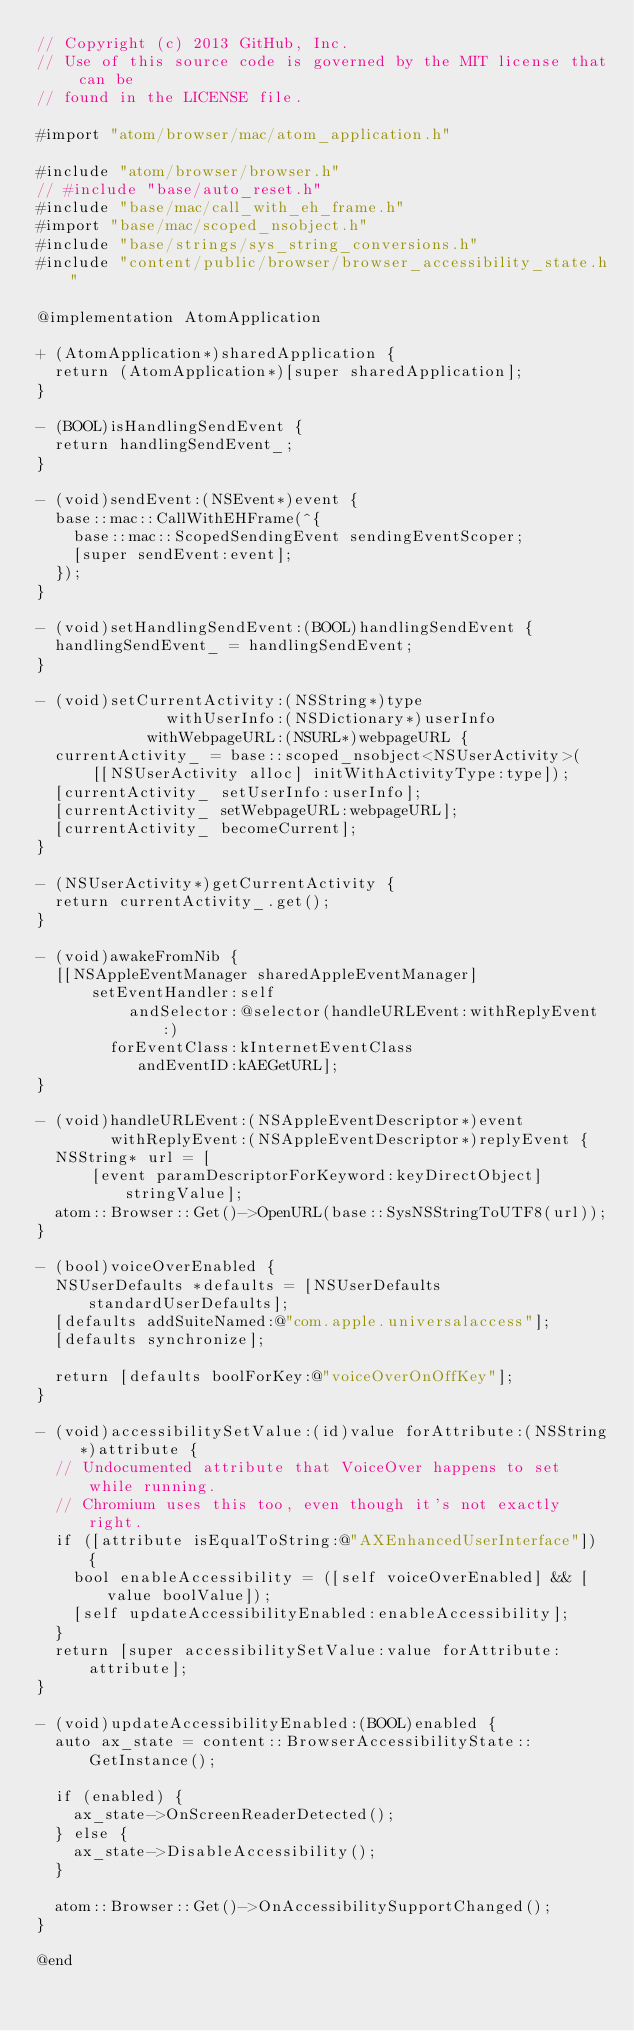Convert code to text. <code><loc_0><loc_0><loc_500><loc_500><_ObjectiveC_>// Copyright (c) 2013 GitHub, Inc.
// Use of this source code is governed by the MIT license that can be
// found in the LICENSE file.

#import "atom/browser/mac/atom_application.h"

#include "atom/browser/browser.h"
// #include "base/auto_reset.h"
#include "base/mac/call_with_eh_frame.h"
#import "base/mac/scoped_nsobject.h"
#include "base/strings/sys_string_conversions.h"
#include "content/public/browser/browser_accessibility_state.h"

@implementation AtomApplication

+ (AtomApplication*)sharedApplication {
  return (AtomApplication*)[super sharedApplication];
}

- (BOOL)isHandlingSendEvent {
  return handlingSendEvent_;
}

- (void)sendEvent:(NSEvent*)event {
  base::mac::CallWithEHFrame(^{
    base::mac::ScopedSendingEvent sendingEventScoper;
    [super sendEvent:event];
  });
}

- (void)setHandlingSendEvent:(BOOL)handlingSendEvent {
  handlingSendEvent_ = handlingSendEvent;
}

- (void)setCurrentActivity:(NSString*)type
              withUserInfo:(NSDictionary*)userInfo
            withWebpageURL:(NSURL*)webpageURL {
  currentActivity_ = base::scoped_nsobject<NSUserActivity>(
      [[NSUserActivity alloc] initWithActivityType:type]);
  [currentActivity_ setUserInfo:userInfo];
  [currentActivity_ setWebpageURL:webpageURL];
  [currentActivity_ becomeCurrent];
}

- (NSUserActivity*)getCurrentActivity {
  return currentActivity_.get();
}

- (void)awakeFromNib {
  [[NSAppleEventManager sharedAppleEventManager]
      setEventHandler:self
          andSelector:@selector(handleURLEvent:withReplyEvent:)
        forEventClass:kInternetEventClass
           andEventID:kAEGetURL];
}

- (void)handleURLEvent:(NSAppleEventDescriptor*)event
        withReplyEvent:(NSAppleEventDescriptor*)replyEvent {
  NSString* url = [
      [event paramDescriptorForKeyword:keyDirectObject] stringValue];
  atom::Browser::Get()->OpenURL(base::SysNSStringToUTF8(url));
}

- (bool)voiceOverEnabled {
  NSUserDefaults *defaults = [NSUserDefaults standardUserDefaults];
  [defaults addSuiteNamed:@"com.apple.universalaccess"];
  [defaults synchronize];

  return [defaults boolForKey:@"voiceOverOnOffKey"];
}

- (void)accessibilitySetValue:(id)value forAttribute:(NSString *)attribute {
  // Undocumented attribute that VoiceOver happens to set while running.
  // Chromium uses this too, even though it's not exactly right.
  if ([attribute isEqualToString:@"AXEnhancedUserInterface"]) {
    bool enableAccessibility = ([self voiceOverEnabled] && [value boolValue]);
    [self updateAccessibilityEnabled:enableAccessibility];
  }
  return [super accessibilitySetValue:value forAttribute:attribute];
}

- (void)updateAccessibilityEnabled:(BOOL)enabled {
  auto ax_state = content::BrowserAccessibilityState::GetInstance();

  if (enabled) {
    ax_state->OnScreenReaderDetected();
  } else {
    ax_state->DisableAccessibility();
  }

  atom::Browser::Get()->OnAccessibilitySupportChanged();
}

@end
</code> 